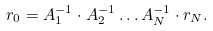<formula> <loc_0><loc_0><loc_500><loc_500>r _ { 0 } = A _ { 1 } ^ { - 1 } \cdot A _ { 2 } ^ { - 1 } \dots A _ { N } ^ { - 1 } \cdot r _ { N } .</formula> 